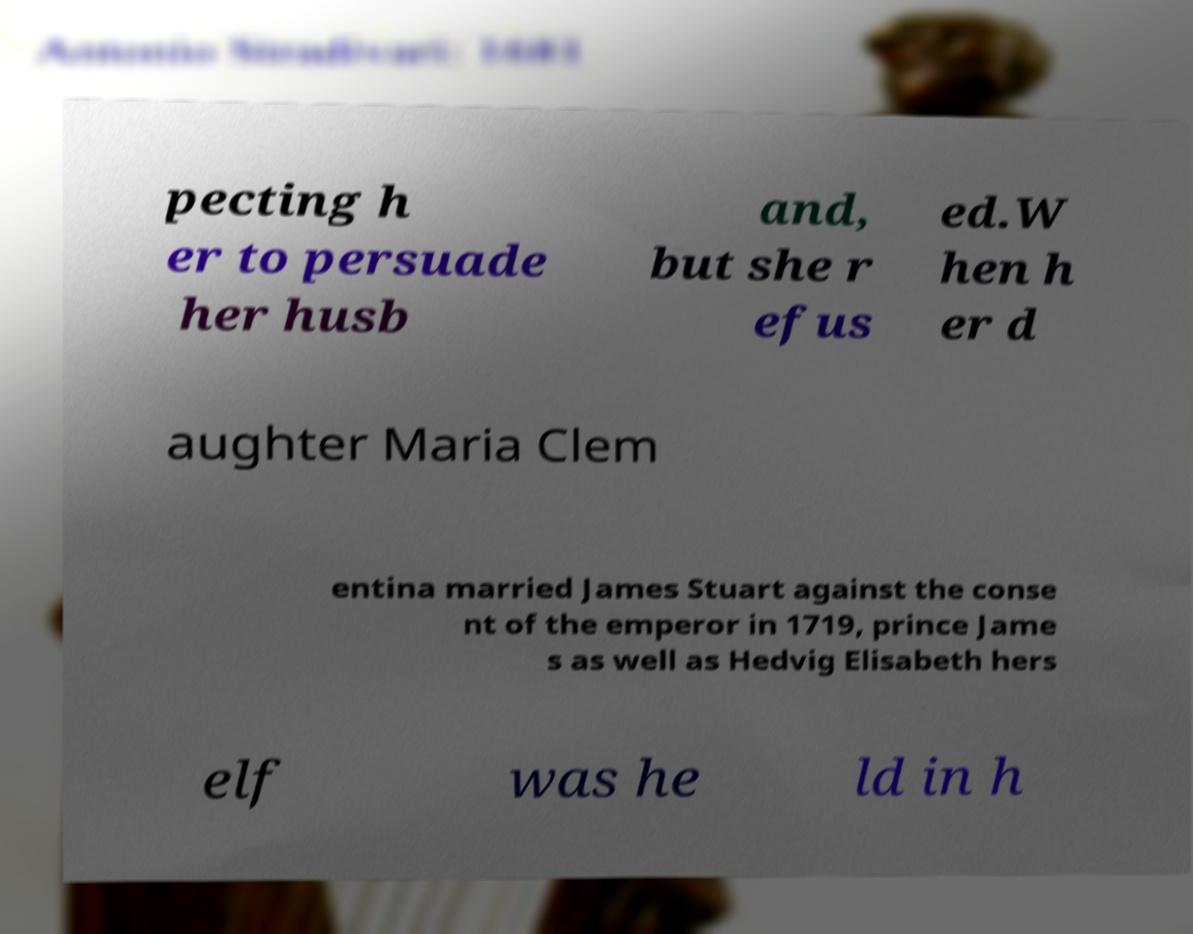Could you assist in decoding the text presented in this image and type it out clearly? pecting h er to persuade her husb and, but she r efus ed.W hen h er d aughter Maria Clem entina married James Stuart against the conse nt of the emperor in 1719, prince Jame s as well as Hedvig Elisabeth hers elf was he ld in h 